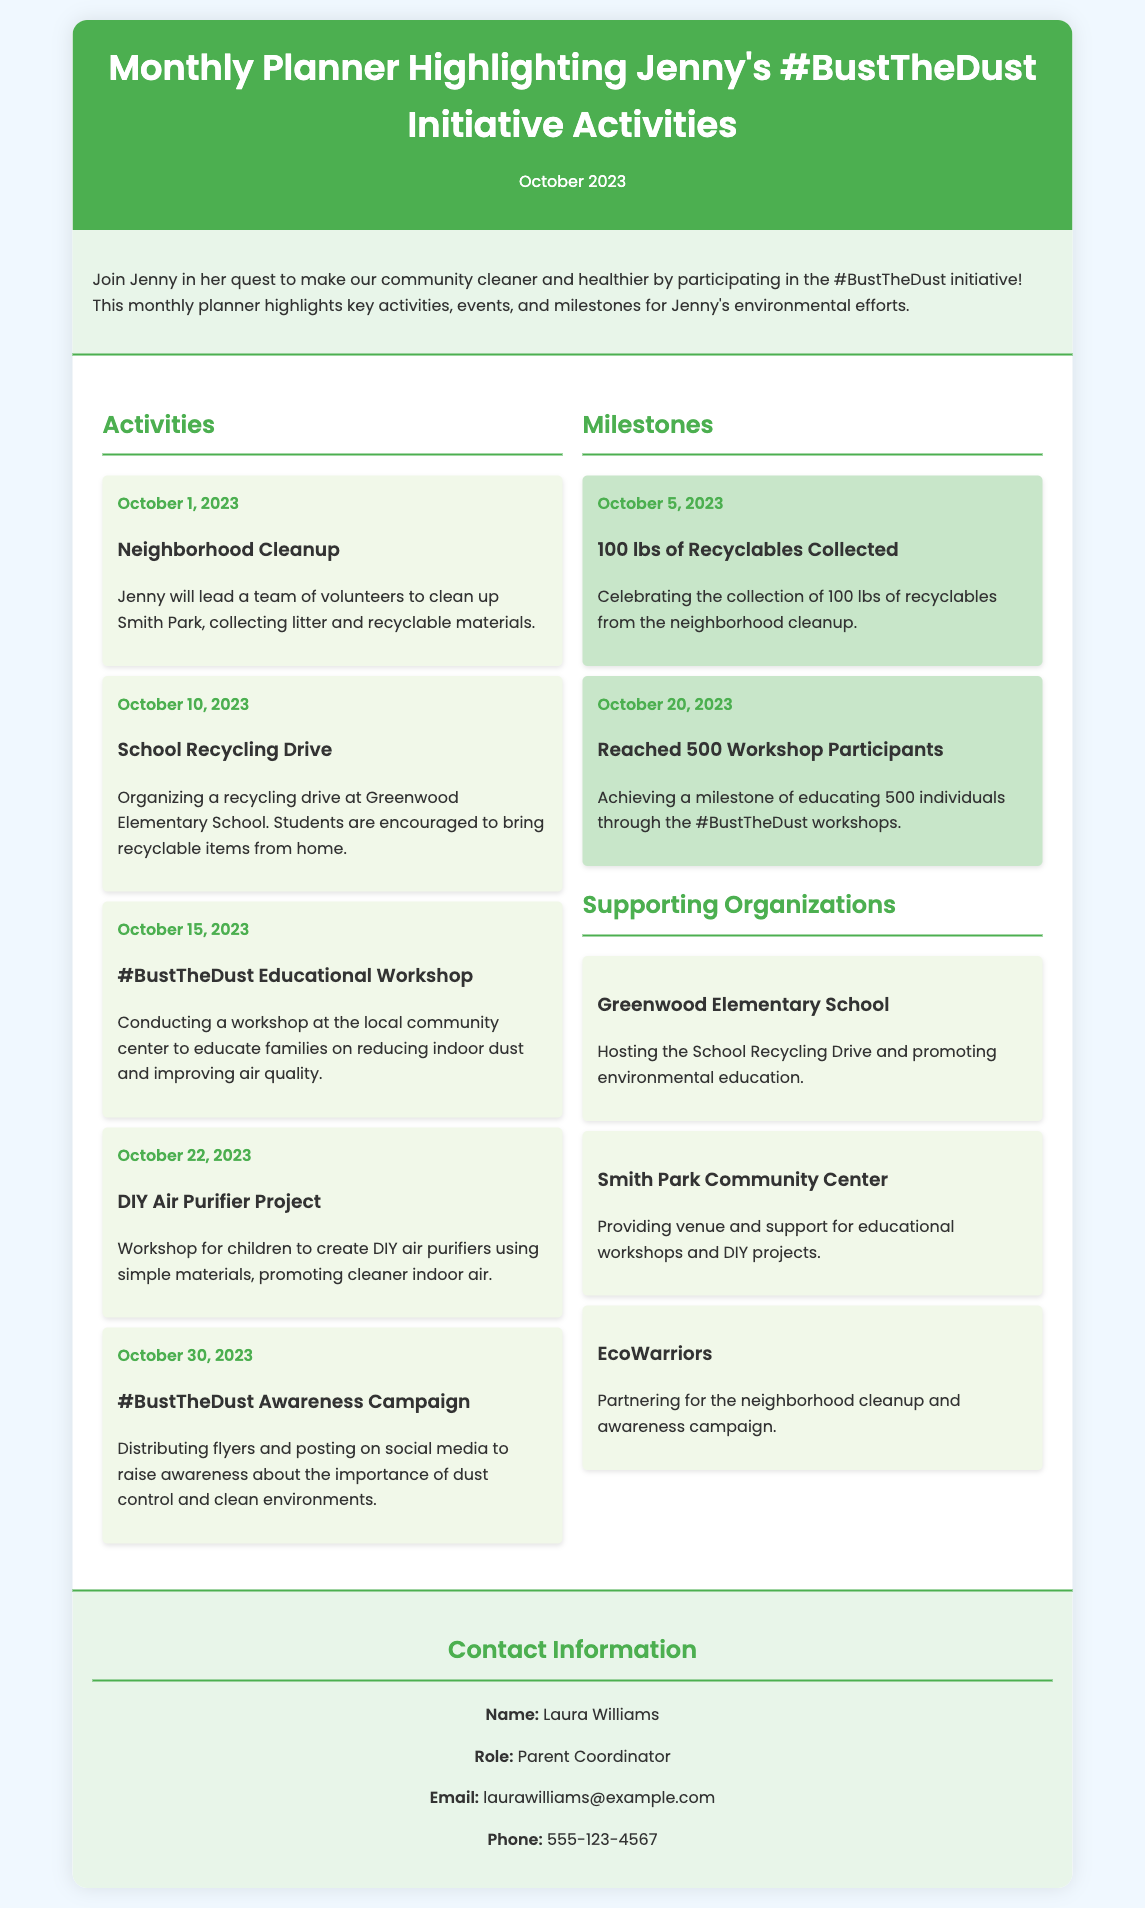What is the title of the planner? The title of the planner is stated at the top of the document.
Answer: Monthly Planner Highlighting Jenny's #BustTheDust Initiative Activities When is the Neighborhood Cleanup scheduled? The specific date for the Neighborhood Cleanup is mentioned in the activities section.
Answer: October 1, 2023 How many workshop participants were reached by October 20, 2023? The document mentions the milestone regarding the number of individuals educated through workshops.
Answer: 500 What is the role of Laura Williams? Laura Williams' role is stated in the contact information section.
Answer: Parent Coordinator Which organization is hosting the School Recycling Drive? The organization responsible for the School Recycling Drive is listed under supporting organizations.
Answer: Greenwood Elementary School What is the date of the DIY Air Purifier Project? The date for the DIY Air Purifier Project is provided in the activities section.
Answer: October 22, 2023 What type of materials will children use in the DIY Air Purifier Project? The document states that simple materials will be used for the DIY Air Purifier Project.
Answer: Simple materials What color is used for the document’s header? The document explicitly states the color used in the header section.
Answer: Green What was collected from the neighborhood cleanup? The document details what was celebrated during a milestone related to cleanup efforts.
Answer: 100 lbs of Recyclables 